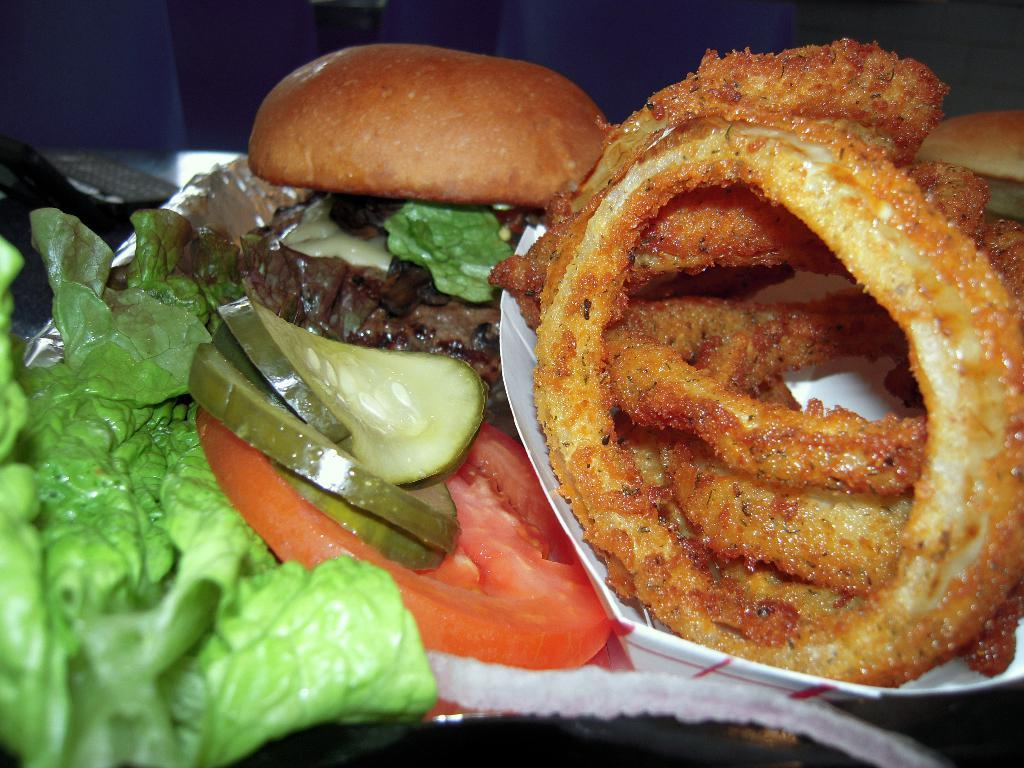What type of food can be seen in the image? There is food in the image, but the specific type cannot be determined from the provided facts. What colors are present in the food? The food has brown, green, red, and cream colors. How is the food presented in the image? The food is on a paper. What color is the paper? The paper is white. Is the father using the oven to cook the food in the image? There is no father or oven present in the image, so this question cannot be answered. 